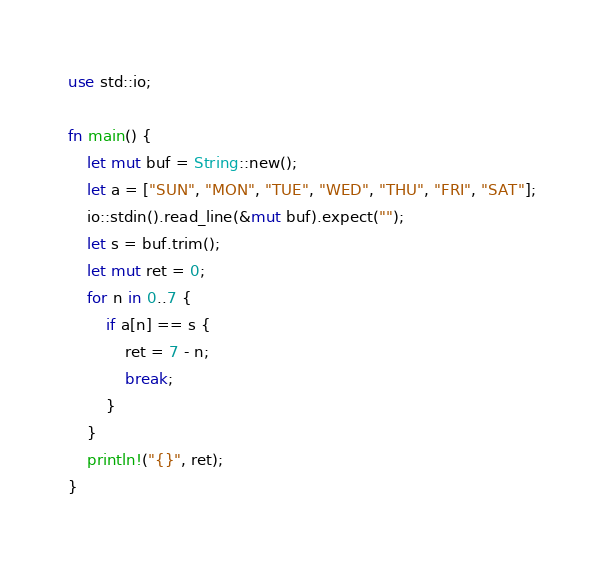<code> <loc_0><loc_0><loc_500><loc_500><_Rust_>use std::io;

fn main() {
	let mut buf = String::new();
	let a = ["SUN", "MON", "TUE", "WED", "THU", "FRI", "SAT"];
	io::stdin().read_line(&mut buf).expect("");
	let s = buf.trim();
	let mut ret = 0;
	for n in 0..7 {
		if a[n] == s {
			ret = 7 - n;
			break;
		}
	}
	println!("{}", ret);
}</code> 